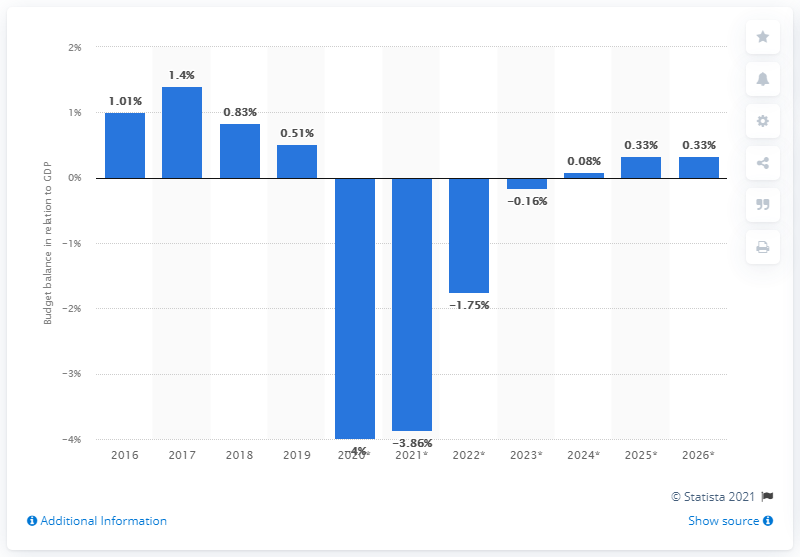Draw attention to some important aspects in this diagram. In 2019, the budget surplus of Sweden amounted to 0.51 percent of the country's GDP. 